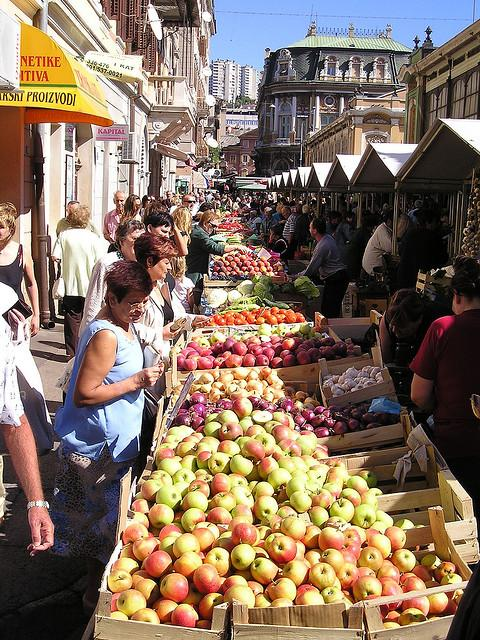Where does a shopper look to see how much a certain fruit costs? cardboard sign 